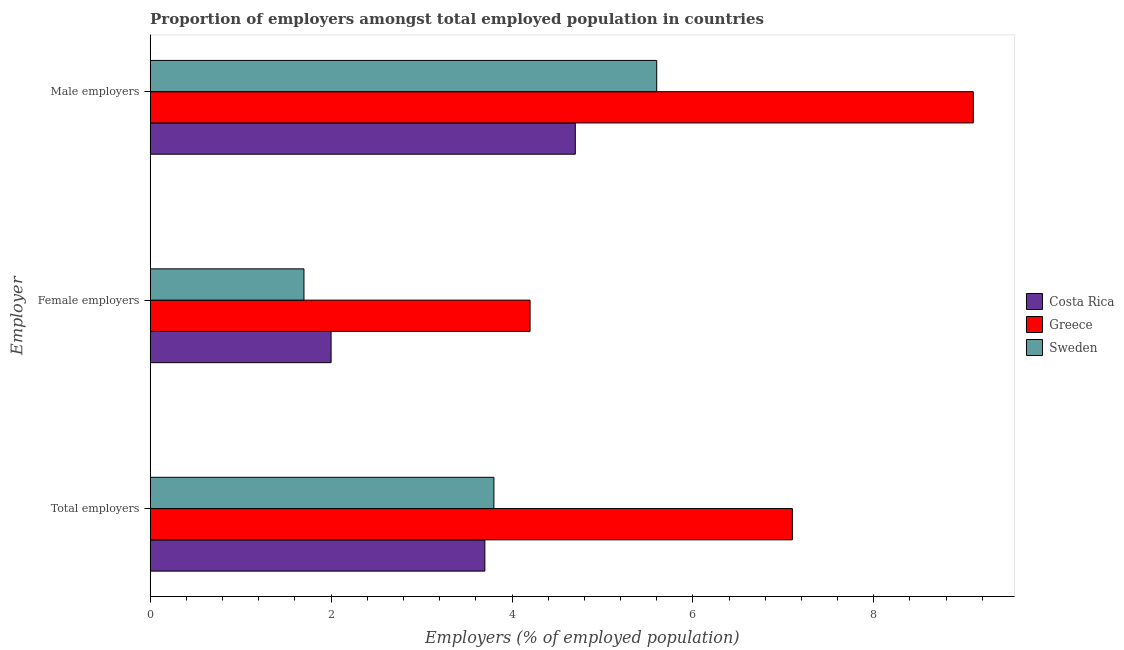How many groups of bars are there?
Your answer should be very brief. 3. How many bars are there on the 1st tick from the top?
Offer a terse response. 3. How many bars are there on the 1st tick from the bottom?
Your answer should be very brief. 3. What is the label of the 1st group of bars from the top?
Ensure brevity in your answer.  Male employers. What is the percentage of male employers in Greece?
Keep it short and to the point. 9.1. Across all countries, what is the maximum percentage of total employers?
Keep it short and to the point. 7.1. Across all countries, what is the minimum percentage of male employers?
Ensure brevity in your answer.  4.7. In which country was the percentage of female employers maximum?
Provide a succinct answer. Greece. In which country was the percentage of male employers minimum?
Provide a succinct answer. Costa Rica. What is the total percentage of male employers in the graph?
Give a very brief answer. 19.4. What is the difference between the percentage of total employers in Costa Rica and that in Sweden?
Ensure brevity in your answer.  -0.1. What is the difference between the percentage of female employers in Greece and the percentage of male employers in Costa Rica?
Keep it short and to the point. -0.5. What is the average percentage of female employers per country?
Provide a succinct answer. 2.63. What is the difference between the percentage of female employers and percentage of total employers in Sweden?
Your answer should be compact. -2.1. In how many countries, is the percentage of total employers greater than 4 %?
Offer a terse response. 1. What is the ratio of the percentage of male employers in Costa Rica to that in Sweden?
Offer a terse response. 0.84. Is the percentage of female employers in Sweden less than that in Costa Rica?
Offer a terse response. Yes. Is the difference between the percentage of female employers in Costa Rica and Greece greater than the difference between the percentage of male employers in Costa Rica and Greece?
Your answer should be compact. Yes. What is the difference between the highest and the second highest percentage of male employers?
Provide a succinct answer. 3.5. What is the difference between the highest and the lowest percentage of total employers?
Your answer should be very brief. 3.4. In how many countries, is the percentage of male employers greater than the average percentage of male employers taken over all countries?
Your answer should be very brief. 1. Is the sum of the percentage of total employers in Sweden and Greece greater than the maximum percentage of female employers across all countries?
Make the answer very short. Yes. What does the 3rd bar from the top in Male employers represents?
Give a very brief answer. Costa Rica. How many bars are there?
Provide a succinct answer. 9. How many countries are there in the graph?
Give a very brief answer. 3. Are the values on the major ticks of X-axis written in scientific E-notation?
Your answer should be very brief. No. Does the graph contain grids?
Offer a very short reply. No. What is the title of the graph?
Give a very brief answer. Proportion of employers amongst total employed population in countries. Does "Guyana" appear as one of the legend labels in the graph?
Offer a very short reply. No. What is the label or title of the X-axis?
Your answer should be very brief. Employers (% of employed population). What is the label or title of the Y-axis?
Offer a very short reply. Employer. What is the Employers (% of employed population) of Costa Rica in Total employers?
Your answer should be very brief. 3.7. What is the Employers (% of employed population) in Greece in Total employers?
Your answer should be very brief. 7.1. What is the Employers (% of employed population) in Sweden in Total employers?
Give a very brief answer. 3.8. What is the Employers (% of employed population) in Greece in Female employers?
Offer a terse response. 4.2. What is the Employers (% of employed population) of Sweden in Female employers?
Your answer should be very brief. 1.7. What is the Employers (% of employed population) in Costa Rica in Male employers?
Your response must be concise. 4.7. What is the Employers (% of employed population) in Greece in Male employers?
Give a very brief answer. 9.1. What is the Employers (% of employed population) in Sweden in Male employers?
Ensure brevity in your answer.  5.6. Across all Employer, what is the maximum Employers (% of employed population) in Costa Rica?
Make the answer very short. 4.7. Across all Employer, what is the maximum Employers (% of employed population) of Greece?
Provide a succinct answer. 9.1. Across all Employer, what is the maximum Employers (% of employed population) of Sweden?
Your answer should be compact. 5.6. Across all Employer, what is the minimum Employers (% of employed population) in Greece?
Your answer should be very brief. 4.2. Across all Employer, what is the minimum Employers (% of employed population) of Sweden?
Your response must be concise. 1.7. What is the total Employers (% of employed population) in Greece in the graph?
Your answer should be compact. 20.4. What is the total Employers (% of employed population) in Sweden in the graph?
Make the answer very short. 11.1. What is the difference between the Employers (% of employed population) of Costa Rica in Total employers and that in Female employers?
Your response must be concise. 1.7. What is the difference between the Employers (% of employed population) in Greece in Total employers and that in Female employers?
Keep it short and to the point. 2.9. What is the difference between the Employers (% of employed population) of Sweden in Total employers and that in Female employers?
Provide a short and direct response. 2.1. What is the difference between the Employers (% of employed population) in Costa Rica in Total employers and that in Male employers?
Ensure brevity in your answer.  -1. What is the difference between the Employers (% of employed population) in Sweden in Total employers and that in Male employers?
Make the answer very short. -1.8. What is the difference between the Employers (% of employed population) of Costa Rica in Female employers and that in Male employers?
Keep it short and to the point. -2.7. What is the difference between the Employers (% of employed population) of Sweden in Female employers and that in Male employers?
Ensure brevity in your answer.  -3.9. What is the difference between the Employers (% of employed population) of Costa Rica in Total employers and the Employers (% of employed population) of Greece in Female employers?
Provide a short and direct response. -0.5. What is the difference between the Employers (% of employed population) in Costa Rica in Total employers and the Employers (% of employed population) in Sweden in Male employers?
Keep it short and to the point. -1.9. What is the difference between the Employers (% of employed population) of Costa Rica in Female employers and the Employers (% of employed population) of Sweden in Male employers?
Make the answer very short. -3.6. What is the difference between the Employers (% of employed population) of Greece in Female employers and the Employers (% of employed population) of Sweden in Male employers?
Keep it short and to the point. -1.4. What is the average Employers (% of employed population) in Costa Rica per Employer?
Make the answer very short. 3.47. What is the average Employers (% of employed population) in Greece per Employer?
Offer a terse response. 6.8. What is the difference between the Employers (% of employed population) of Costa Rica and Employers (% of employed population) of Greece in Total employers?
Provide a succinct answer. -3.4. What is the difference between the Employers (% of employed population) in Costa Rica and Employers (% of employed population) in Sweden in Total employers?
Your response must be concise. -0.1. What is the difference between the Employers (% of employed population) of Greece and Employers (% of employed population) of Sweden in Total employers?
Offer a terse response. 3.3. What is the difference between the Employers (% of employed population) of Costa Rica and Employers (% of employed population) of Sweden in Female employers?
Keep it short and to the point. 0.3. What is the difference between the Employers (% of employed population) in Greece and Employers (% of employed population) in Sweden in Female employers?
Your response must be concise. 2.5. What is the difference between the Employers (% of employed population) of Costa Rica and Employers (% of employed population) of Greece in Male employers?
Make the answer very short. -4.4. What is the difference between the Employers (% of employed population) of Greece and Employers (% of employed population) of Sweden in Male employers?
Give a very brief answer. 3.5. What is the ratio of the Employers (% of employed population) in Costa Rica in Total employers to that in Female employers?
Make the answer very short. 1.85. What is the ratio of the Employers (% of employed population) in Greece in Total employers to that in Female employers?
Your answer should be compact. 1.69. What is the ratio of the Employers (% of employed population) in Sweden in Total employers to that in Female employers?
Offer a terse response. 2.24. What is the ratio of the Employers (% of employed population) in Costa Rica in Total employers to that in Male employers?
Your answer should be compact. 0.79. What is the ratio of the Employers (% of employed population) of Greece in Total employers to that in Male employers?
Provide a succinct answer. 0.78. What is the ratio of the Employers (% of employed population) in Sweden in Total employers to that in Male employers?
Make the answer very short. 0.68. What is the ratio of the Employers (% of employed population) in Costa Rica in Female employers to that in Male employers?
Your answer should be very brief. 0.43. What is the ratio of the Employers (% of employed population) of Greece in Female employers to that in Male employers?
Your response must be concise. 0.46. What is the ratio of the Employers (% of employed population) in Sweden in Female employers to that in Male employers?
Give a very brief answer. 0.3. What is the difference between the highest and the lowest Employers (% of employed population) of Greece?
Ensure brevity in your answer.  4.9. 